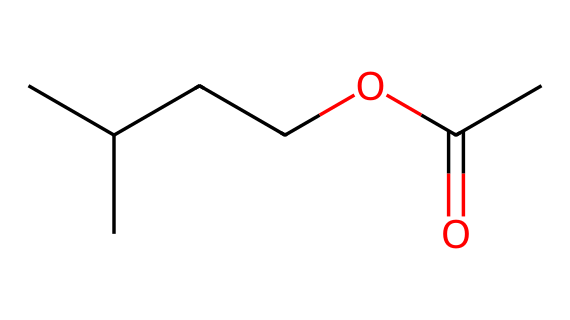What is the common name for this compound? The SMILES representation shows a structure typically associated with isoamyl acetate, which is commonly known for its banana-like aroma.
Answer: isoamyl acetate How many carbon atoms are present in this molecule? Looking at the SMILES structure CC(C)CCOC(=O)C, we can count a total of 5 carbon atoms in the chain plus 1 carbon in the acetate group, totaling 6 carbon atoms.
Answer: 6 What functional group characterizes this compound as an ester? The presence of the O=C-O bond (the carbonyl and the single-bonded oxygen) indicates that this compound has the structure of an ester.
Answer: ester What type of interaction is responsible for the fruity aroma of isoamyl acetate? The chemical structure contains carbon chains and functional groups that allow for volatile compounds, which can interact with olfactory receptors, producing a fruity aroma.
Answer: volatile interaction Which part of the molecule is responsible for its characteristic aroma? The ethyl acetate group, particularly the isoamyl portion (the carbon chain), gives this molecule its distinctive banana-like smell.
Answer: isoamyl group 